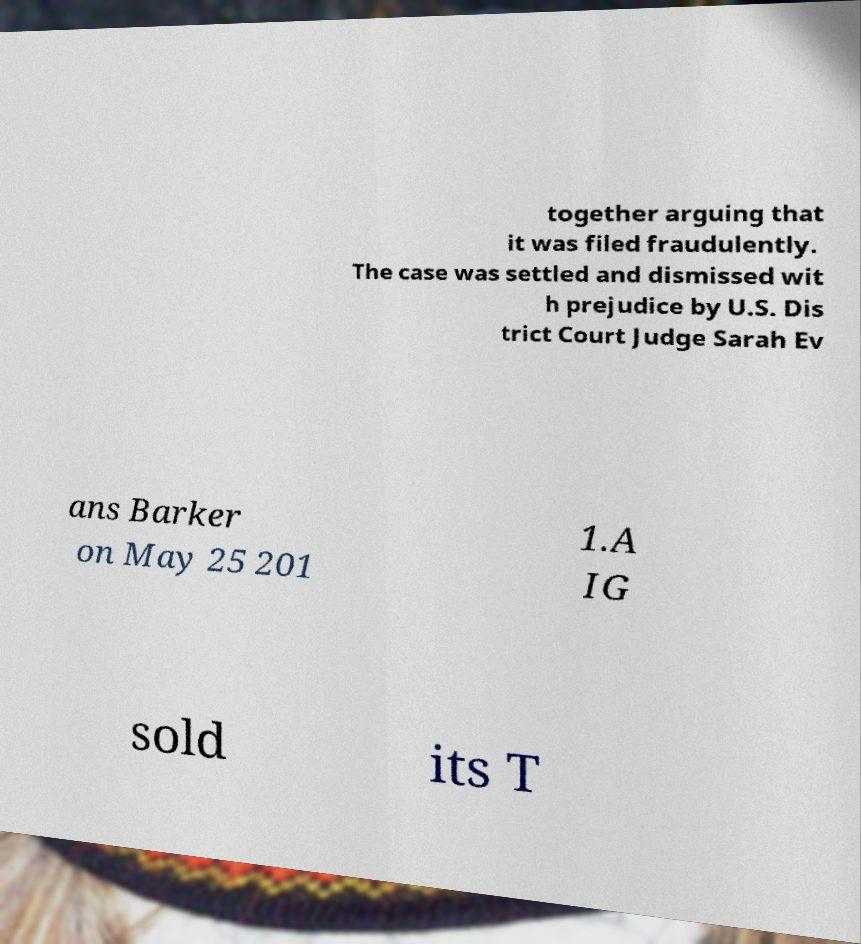Can you accurately transcribe the text from the provided image for me? together arguing that it was filed fraudulently. The case was settled and dismissed wit h prejudice by U.S. Dis trict Court Judge Sarah Ev ans Barker on May 25 201 1.A IG sold its T 